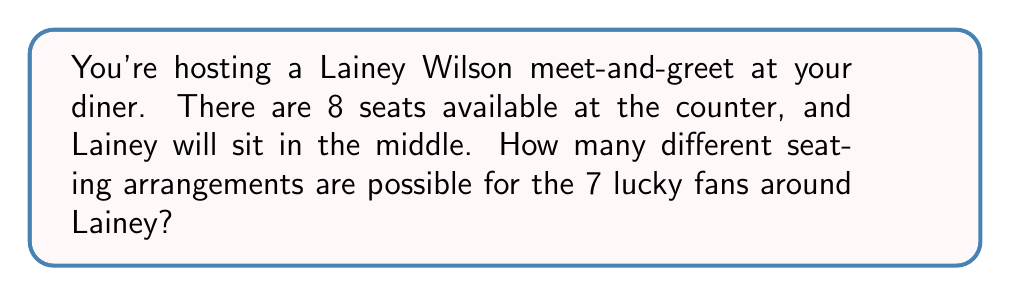Could you help me with this problem? Let's approach this step-by-step:

1) First, we need to understand the setup:
   - There are 8 seats at the counter.
   - Lainey Wilson will sit in the middle, which is a fixed position.
   - This leaves 7 seats for the fans: 3 on one side of Lainey and 4 on the other side.

2) Now, we need to arrange 7 fans in these 7 seats.

3) This is a straightforward permutation problem. We're arranging 7 distinct people in 7 distinct seats.

4) The formula for permutations is:

   $$P(n) = n!$$

   Where $n$ is the number of items to arrange.

5) In this case, $n = 7$, so we have:

   $$P(7) = 7!$$

6) Let's calculate this:
   
   $$7! = 7 \times 6 \times 5 \times 4 \times 3 \times 2 \times 1 = 5040$$

Therefore, there are 5040 different possible seating arrangements for the 7 fans around Lainey Wilson at the diner counter.
Answer: 5040 